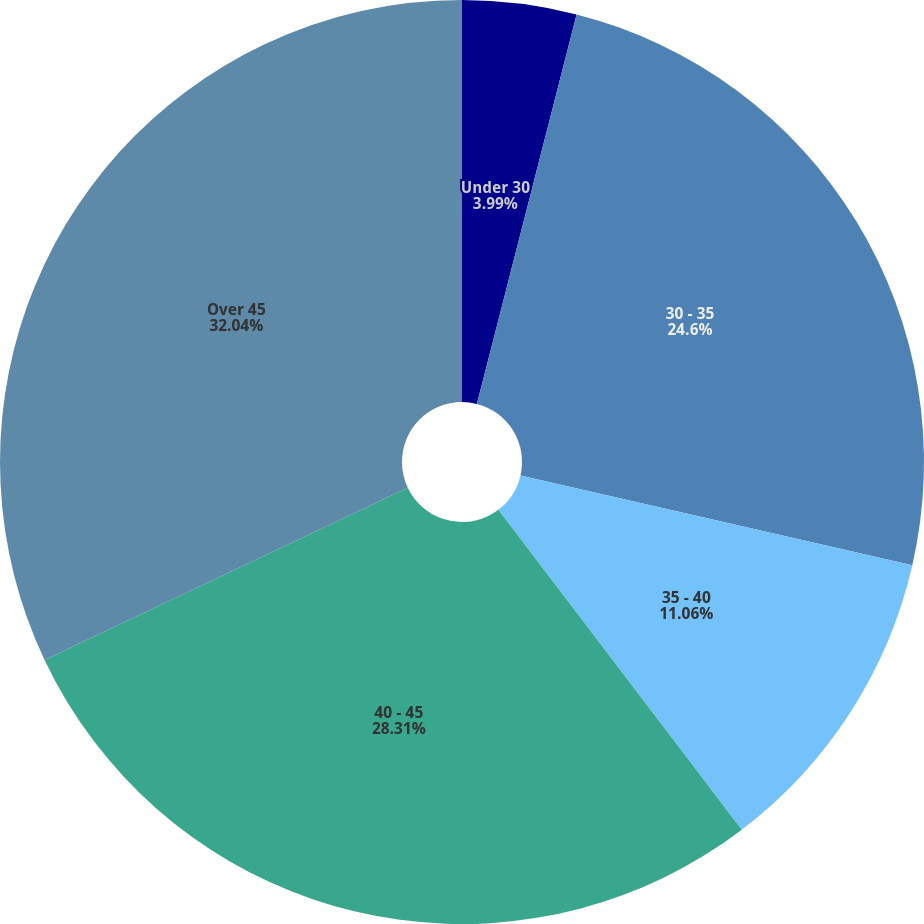<chart> <loc_0><loc_0><loc_500><loc_500><pie_chart><fcel>Under 30<fcel>30 - 35<fcel>35 - 40<fcel>40 - 45<fcel>Over 45<nl><fcel>3.99%<fcel>24.6%<fcel>11.06%<fcel>28.31%<fcel>32.05%<nl></chart> 